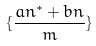<formula> <loc_0><loc_0><loc_500><loc_500>\{ \frac { a n ^ { * } + b n } { m } \}</formula> 